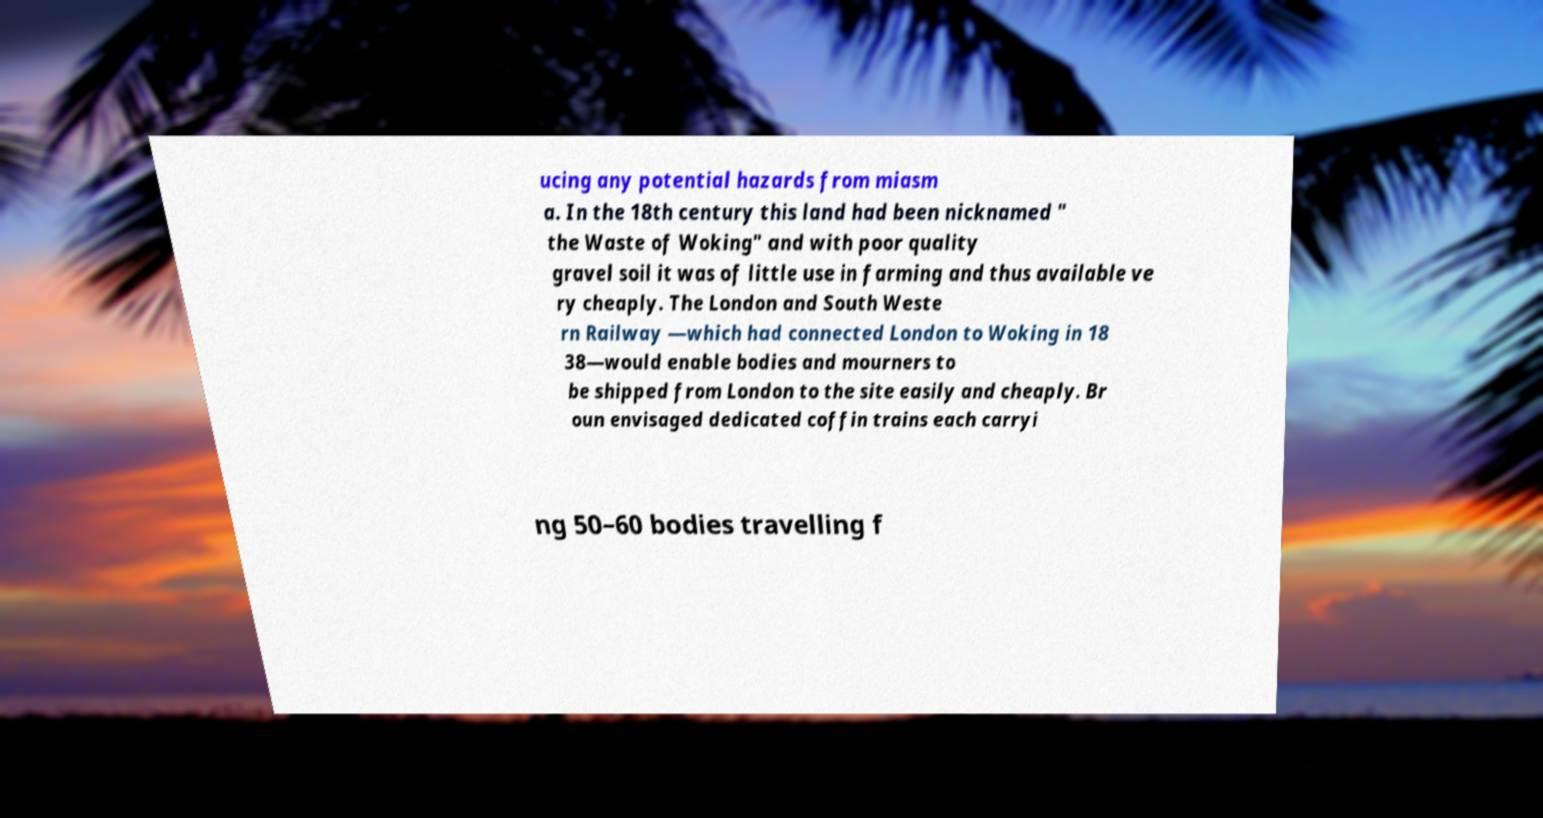What messages or text are displayed in this image? I need them in a readable, typed format. ucing any potential hazards from miasm a. In the 18th century this land had been nicknamed " the Waste of Woking" and with poor quality gravel soil it was of little use in farming and thus available ve ry cheaply. The London and South Weste rn Railway —which had connected London to Woking in 18 38—would enable bodies and mourners to be shipped from London to the site easily and cheaply. Br oun envisaged dedicated coffin trains each carryi ng 50–60 bodies travelling f 